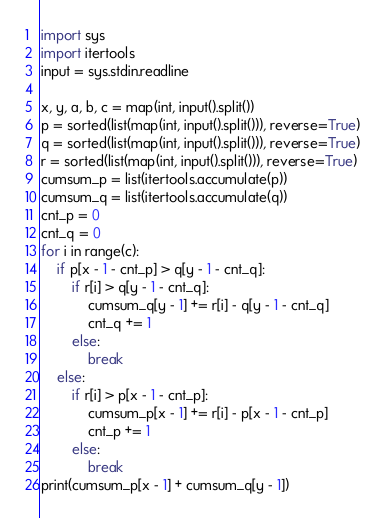Convert code to text. <code><loc_0><loc_0><loc_500><loc_500><_Python_>import sys
import itertools
input = sys.stdin.readline

x, y, a, b, c = map(int, input().split())
p = sorted(list(map(int, input().split())), reverse=True)
q = sorted(list(map(int, input().split())), reverse=True)
r = sorted(list(map(int, input().split())), reverse=True)
cumsum_p = list(itertools.accumulate(p))
cumsum_q = list(itertools.accumulate(q))
cnt_p = 0
cnt_q = 0
for i in range(c):
    if p[x - 1 - cnt_p] > q[y - 1 - cnt_q]:
        if r[i] > q[y - 1 - cnt_q]:
            cumsum_q[y - 1] += r[i] - q[y - 1 - cnt_q]
            cnt_q += 1
        else:
            break
    else:
        if r[i] > p[x - 1 - cnt_p]:
            cumsum_p[x - 1] += r[i] - p[x - 1 - cnt_p]
            cnt_p += 1
        else:
            break
print(cumsum_p[x - 1] + cumsum_q[y - 1])
</code> 